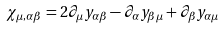Convert formula to latex. <formula><loc_0><loc_0><loc_500><loc_500>\chi _ { \mu , \alpha \beta } = 2 \partial _ { \mu } y _ { \alpha \beta } - \partial _ { \alpha } y _ { \beta \mu } + \partial _ { \beta } y _ { \alpha \mu }</formula> 